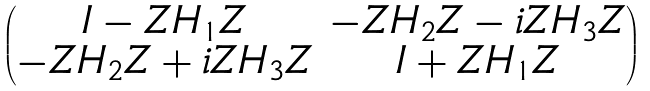Convert formula to latex. <formula><loc_0><loc_0><loc_500><loc_500>\begin{pmatrix} I - Z H _ { 1 } Z & - Z H _ { 2 } Z - i Z H _ { 3 } Z \\ - Z H _ { 2 } Z + i Z H _ { 3 } Z & I + Z H _ { 1 } Z \end{pmatrix}</formula> 